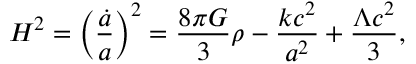Convert formula to latex. <formula><loc_0><loc_0><loc_500><loc_500>H ^ { 2 } = \left ( { \frac { \dot { a } } { a } } \right ) ^ { 2 } = { \frac { 8 \pi G } { 3 } } \rho - { \frac { k c ^ { 2 } } { a ^ { 2 } } } + { \frac { \Lambda c ^ { 2 } } { 3 } } ,</formula> 